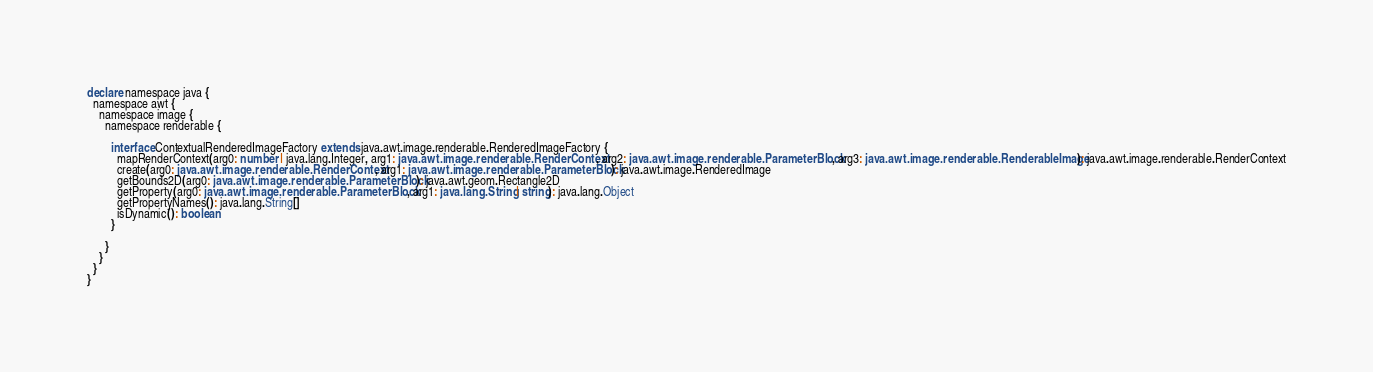Convert code to text. <code><loc_0><loc_0><loc_500><loc_500><_TypeScript_>declare namespace java {
  namespace awt {
    namespace image {
      namespace renderable {

        interface ContextualRenderedImageFactory extends java.awt.image.renderable.RenderedImageFactory {
          mapRenderContext(arg0: number | java.lang.Integer, arg1: java.awt.image.renderable.RenderContext, arg2: java.awt.image.renderable.ParameterBlock, arg3: java.awt.image.renderable.RenderableImage): java.awt.image.renderable.RenderContext
          create(arg0: java.awt.image.renderable.RenderContext, arg1: java.awt.image.renderable.ParameterBlock): java.awt.image.RenderedImage
          getBounds2D(arg0: java.awt.image.renderable.ParameterBlock): java.awt.geom.Rectangle2D
          getProperty(arg0: java.awt.image.renderable.ParameterBlock, arg1: java.lang.String | string): java.lang.Object
          getPropertyNames(): java.lang.String[]
          isDynamic(): boolean
        }

      }
    }
  }
}
</code> 